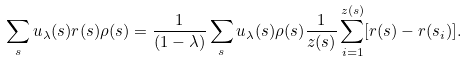<formula> <loc_0><loc_0><loc_500><loc_500>\sum _ { s } u _ { \lambda } ( s ) { r } ( s ) \rho ( s ) = \frac { 1 } { ( 1 - { \lambda } ) } \sum _ { s } u _ { \lambda } ( s ) \rho ( s ) \frac { 1 } { z ( s ) } \sum _ { i = 1 } ^ { z ( s ) } [ { r ( s ) } - { r } ( s _ { i } ) ] .</formula> 